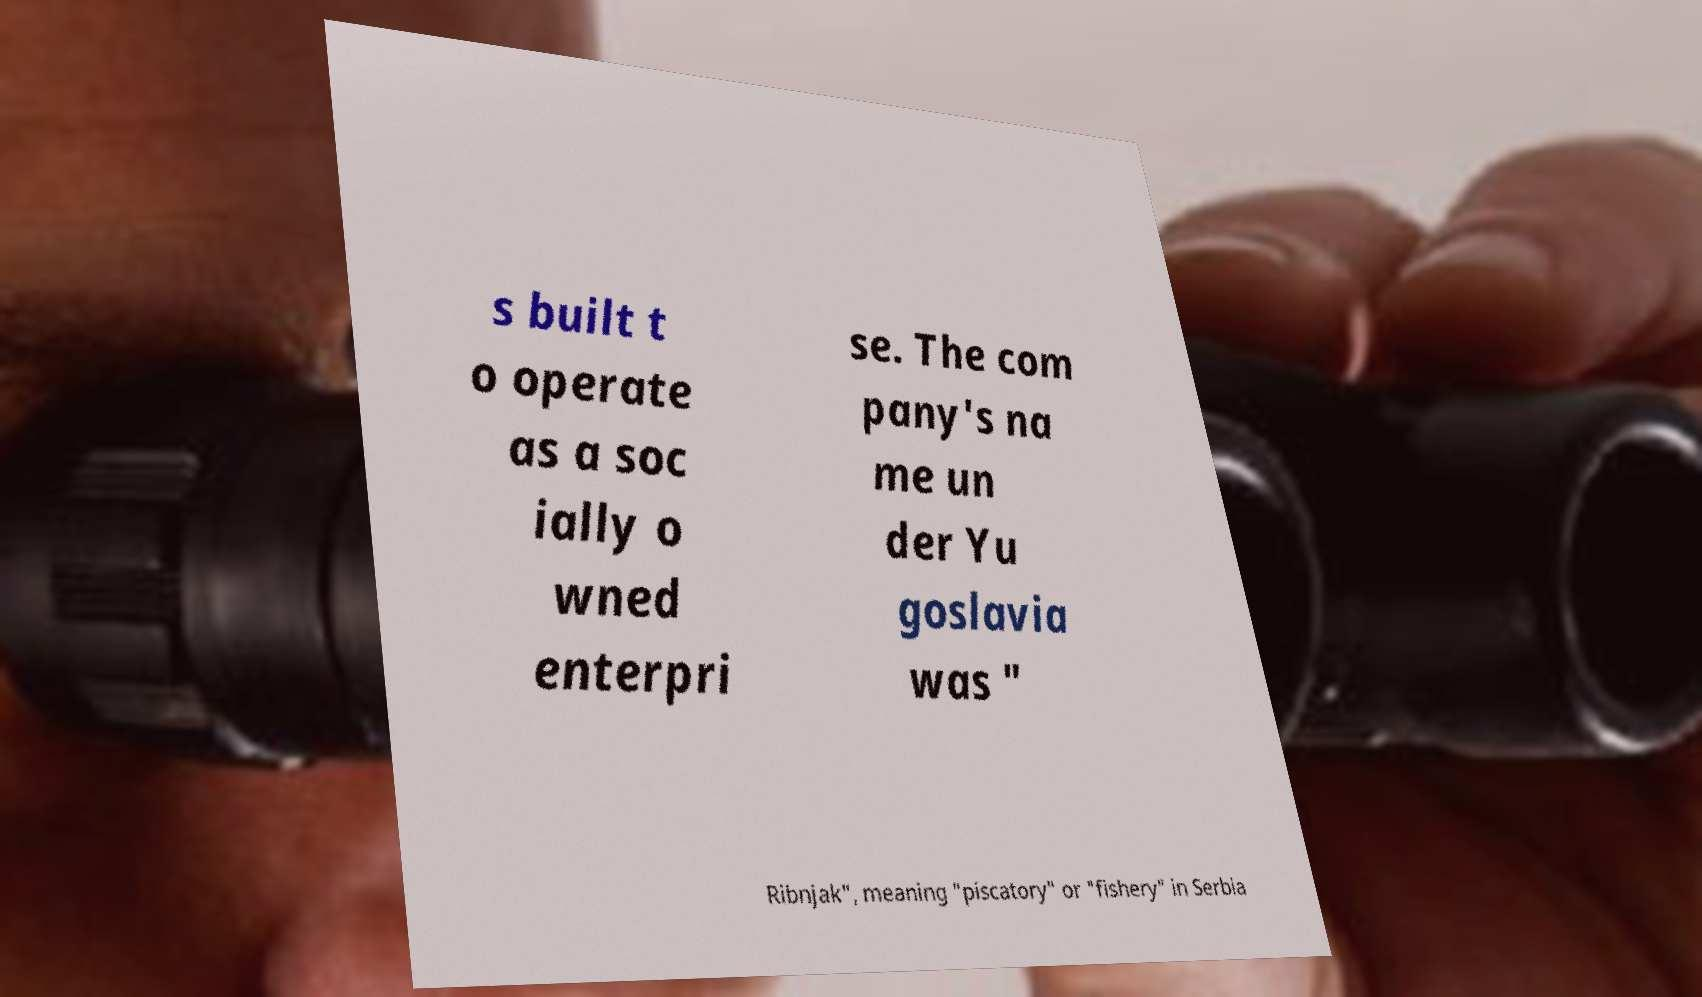Please identify and transcribe the text found in this image. s built t o operate as a soc ially o wned enterpri se. The com pany's na me un der Yu goslavia was " Ribnjak", meaning "piscatory" or "fishery" in Serbia 